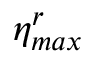Convert formula to latex. <formula><loc_0><loc_0><loc_500><loc_500>\eta _ { \max } ^ { r }</formula> 